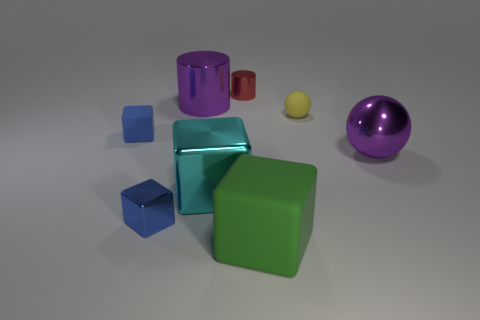Add 1 small balls. How many objects exist? 9 Subtract all balls. How many objects are left? 6 Add 5 large blue spheres. How many large blue spheres exist? 5 Subtract 0 blue spheres. How many objects are left? 8 Subtract all large cylinders. Subtract all small cylinders. How many objects are left? 6 Add 1 purple metal cylinders. How many purple metal cylinders are left? 2 